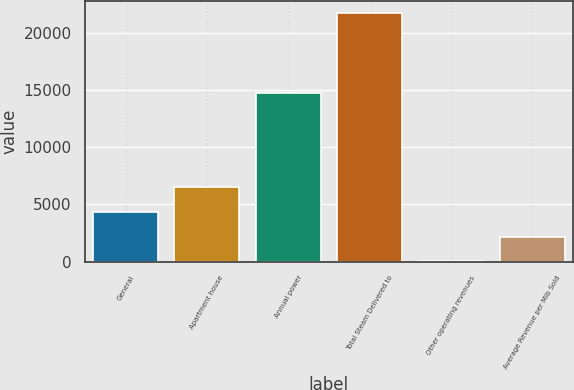Convert chart to OTSL. <chart><loc_0><loc_0><loc_500><loc_500><bar_chart><fcel>General<fcel>Apartment house<fcel>Annual power<fcel>Total Steam Delivered to<fcel>Other operating revenues<fcel>Average Revenue per Mlb Sold<nl><fcel>4363.6<fcel>6538.4<fcel>14811<fcel>21762<fcel>14<fcel>2188.8<nl></chart> 